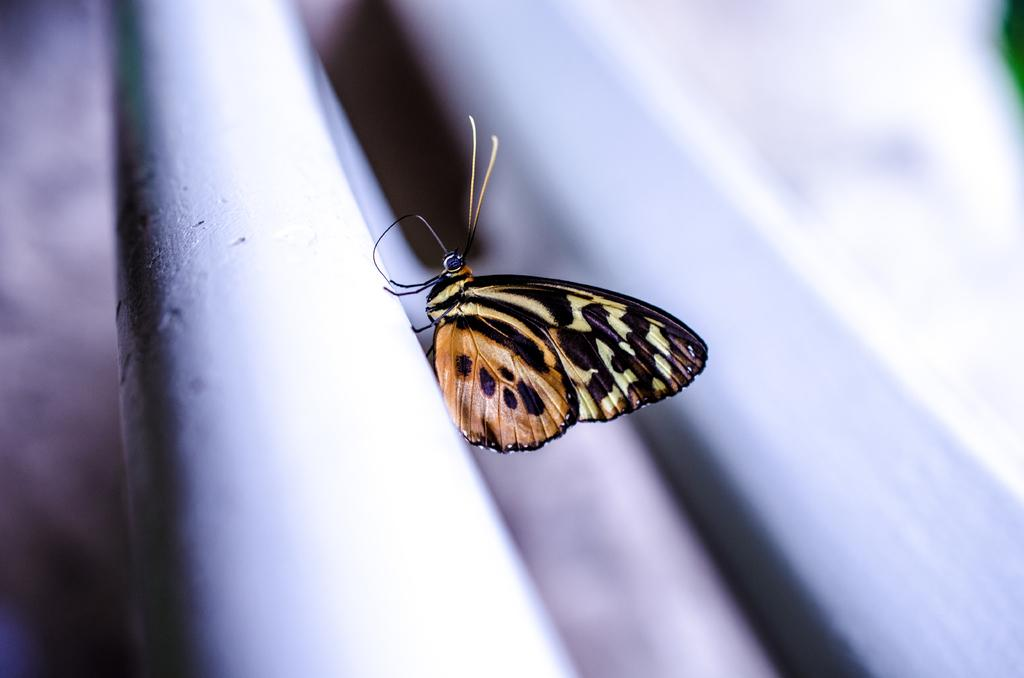What is the main subject of the picture? There is a butterfly in the picture. Can you describe the background of the image? The background of the image is blurry. Where is the sink located in the image? There is no sink present in the image; it features a butterfly with a blurry background. What type of story is being told in the image? The image does not depict a story; it simply shows a butterfly with a blurry background. 